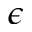Convert formula to latex. <formula><loc_0><loc_0><loc_500><loc_500>\epsilon</formula> 